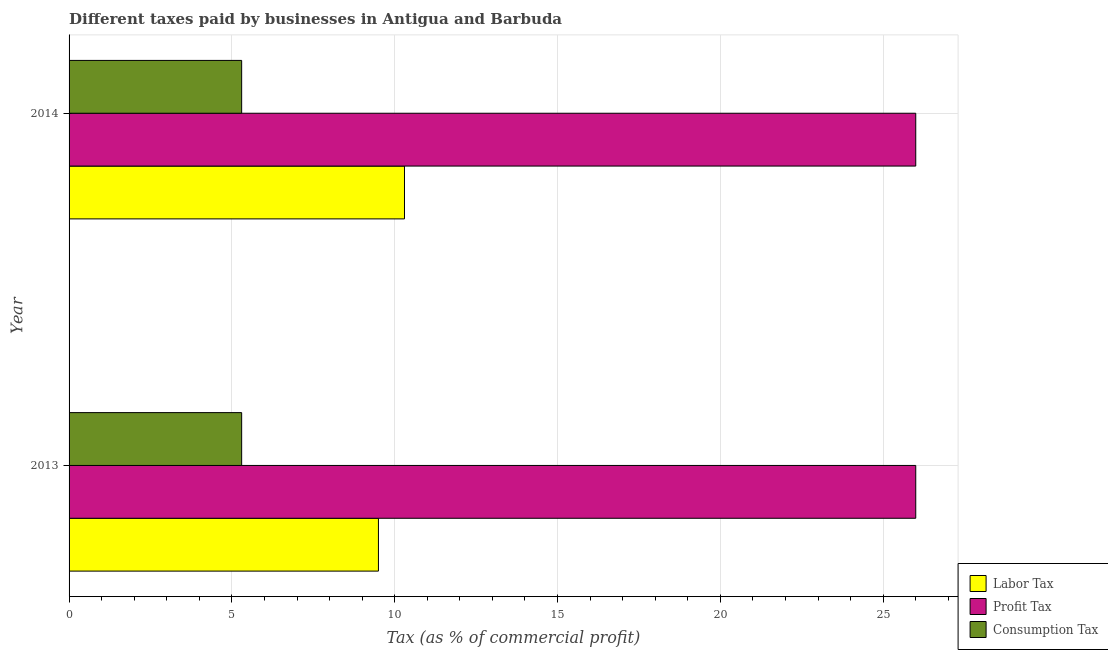How many different coloured bars are there?
Ensure brevity in your answer.  3. Are the number of bars per tick equal to the number of legend labels?
Make the answer very short. Yes. How many bars are there on the 2nd tick from the top?
Your answer should be very brief. 3. What is the label of the 1st group of bars from the top?
Give a very brief answer. 2014. In how many cases, is the number of bars for a given year not equal to the number of legend labels?
Your answer should be compact. 0. What is the percentage of profit tax in 2013?
Provide a succinct answer. 26. In which year was the percentage of consumption tax maximum?
Ensure brevity in your answer.  2013. In which year was the percentage of profit tax minimum?
Make the answer very short. 2013. What is the total percentage of labor tax in the graph?
Ensure brevity in your answer.  19.8. What is the difference between the percentage of consumption tax in 2013 and the percentage of profit tax in 2014?
Provide a short and direct response. -20.7. In the year 2014, what is the difference between the percentage of labor tax and percentage of profit tax?
Offer a very short reply. -15.7. What is the ratio of the percentage of profit tax in 2013 to that in 2014?
Your response must be concise. 1. In how many years, is the percentage of profit tax greater than the average percentage of profit tax taken over all years?
Ensure brevity in your answer.  0. What does the 1st bar from the top in 2013 represents?
Keep it short and to the point. Consumption Tax. What does the 3rd bar from the bottom in 2014 represents?
Your answer should be very brief. Consumption Tax. Is it the case that in every year, the sum of the percentage of labor tax and percentage of profit tax is greater than the percentage of consumption tax?
Ensure brevity in your answer.  Yes. How many bars are there?
Ensure brevity in your answer.  6. Are all the bars in the graph horizontal?
Your response must be concise. Yes. What is the difference between two consecutive major ticks on the X-axis?
Your answer should be compact. 5. Does the graph contain grids?
Your answer should be very brief. Yes. What is the title of the graph?
Keep it short and to the point. Different taxes paid by businesses in Antigua and Barbuda. What is the label or title of the X-axis?
Your answer should be very brief. Tax (as % of commercial profit). What is the label or title of the Y-axis?
Provide a succinct answer. Year. What is the Tax (as % of commercial profit) of Labor Tax in 2013?
Offer a terse response. 9.5. What is the Tax (as % of commercial profit) of Profit Tax in 2013?
Offer a terse response. 26. What is the Tax (as % of commercial profit) in Consumption Tax in 2014?
Your answer should be compact. 5.3. Across all years, what is the maximum Tax (as % of commercial profit) of Consumption Tax?
Give a very brief answer. 5.3. Across all years, what is the minimum Tax (as % of commercial profit) of Profit Tax?
Your answer should be compact. 26. Across all years, what is the minimum Tax (as % of commercial profit) in Consumption Tax?
Provide a short and direct response. 5.3. What is the total Tax (as % of commercial profit) in Labor Tax in the graph?
Your answer should be compact. 19.8. What is the difference between the Tax (as % of commercial profit) in Profit Tax in 2013 and that in 2014?
Give a very brief answer. 0. What is the difference between the Tax (as % of commercial profit) of Labor Tax in 2013 and the Tax (as % of commercial profit) of Profit Tax in 2014?
Offer a very short reply. -16.5. What is the difference between the Tax (as % of commercial profit) of Labor Tax in 2013 and the Tax (as % of commercial profit) of Consumption Tax in 2014?
Your answer should be very brief. 4.2. What is the difference between the Tax (as % of commercial profit) in Profit Tax in 2013 and the Tax (as % of commercial profit) in Consumption Tax in 2014?
Your answer should be very brief. 20.7. What is the average Tax (as % of commercial profit) in Consumption Tax per year?
Keep it short and to the point. 5.3. In the year 2013, what is the difference between the Tax (as % of commercial profit) in Labor Tax and Tax (as % of commercial profit) in Profit Tax?
Your answer should be compact. -16.5. In the year 2013, what is the difference between the Tax (as % of commercial profit) in Profit Tax and Tax (as % of commercial profit) in Consumption Tax?
Make the answer very short. 20.7. In the year 2014, what is the difference between the Tax (as % of commercial profit) of Labor Tax and Tax (as % of commercial profit) of Profit Tax?
Make the answer very short. -15.7. In the year 2014, what is the difference between the Tax (as % of commercial profit) of Profit Tax and Tax (as % of commercial profit) of Consumption Tax?
Your answer should be compact. 20.7. What is the ratio of the Tax (as % of commercial profit) in Labor Tax in 2013 to that in 2014?
Provide a succinct answer. 0.92. What is the ratio of the Tax (as % of commercial profit) of Consumption Tax in 2013 to that in 2014?
Ensure brevity in your answer.  1. What is the difference between the highest and the second highest Tax (as % of commercial profit) in Profit Tax?
Give a very brief answer. 0. What is the difference between the highest and the second highest Tax (as % of commercial profit) of Consumption Tax?
Your answer should be very brief. 0. What is the difference between the highest and the lowest Tax (as % of commercial profit) in Labor Tax?
Your response must be concise. 0.8. What is the difference between the highest and the lowest Tax (as % of commercial profit) of Profit Tax?
Your answer should be very brief. 0. 